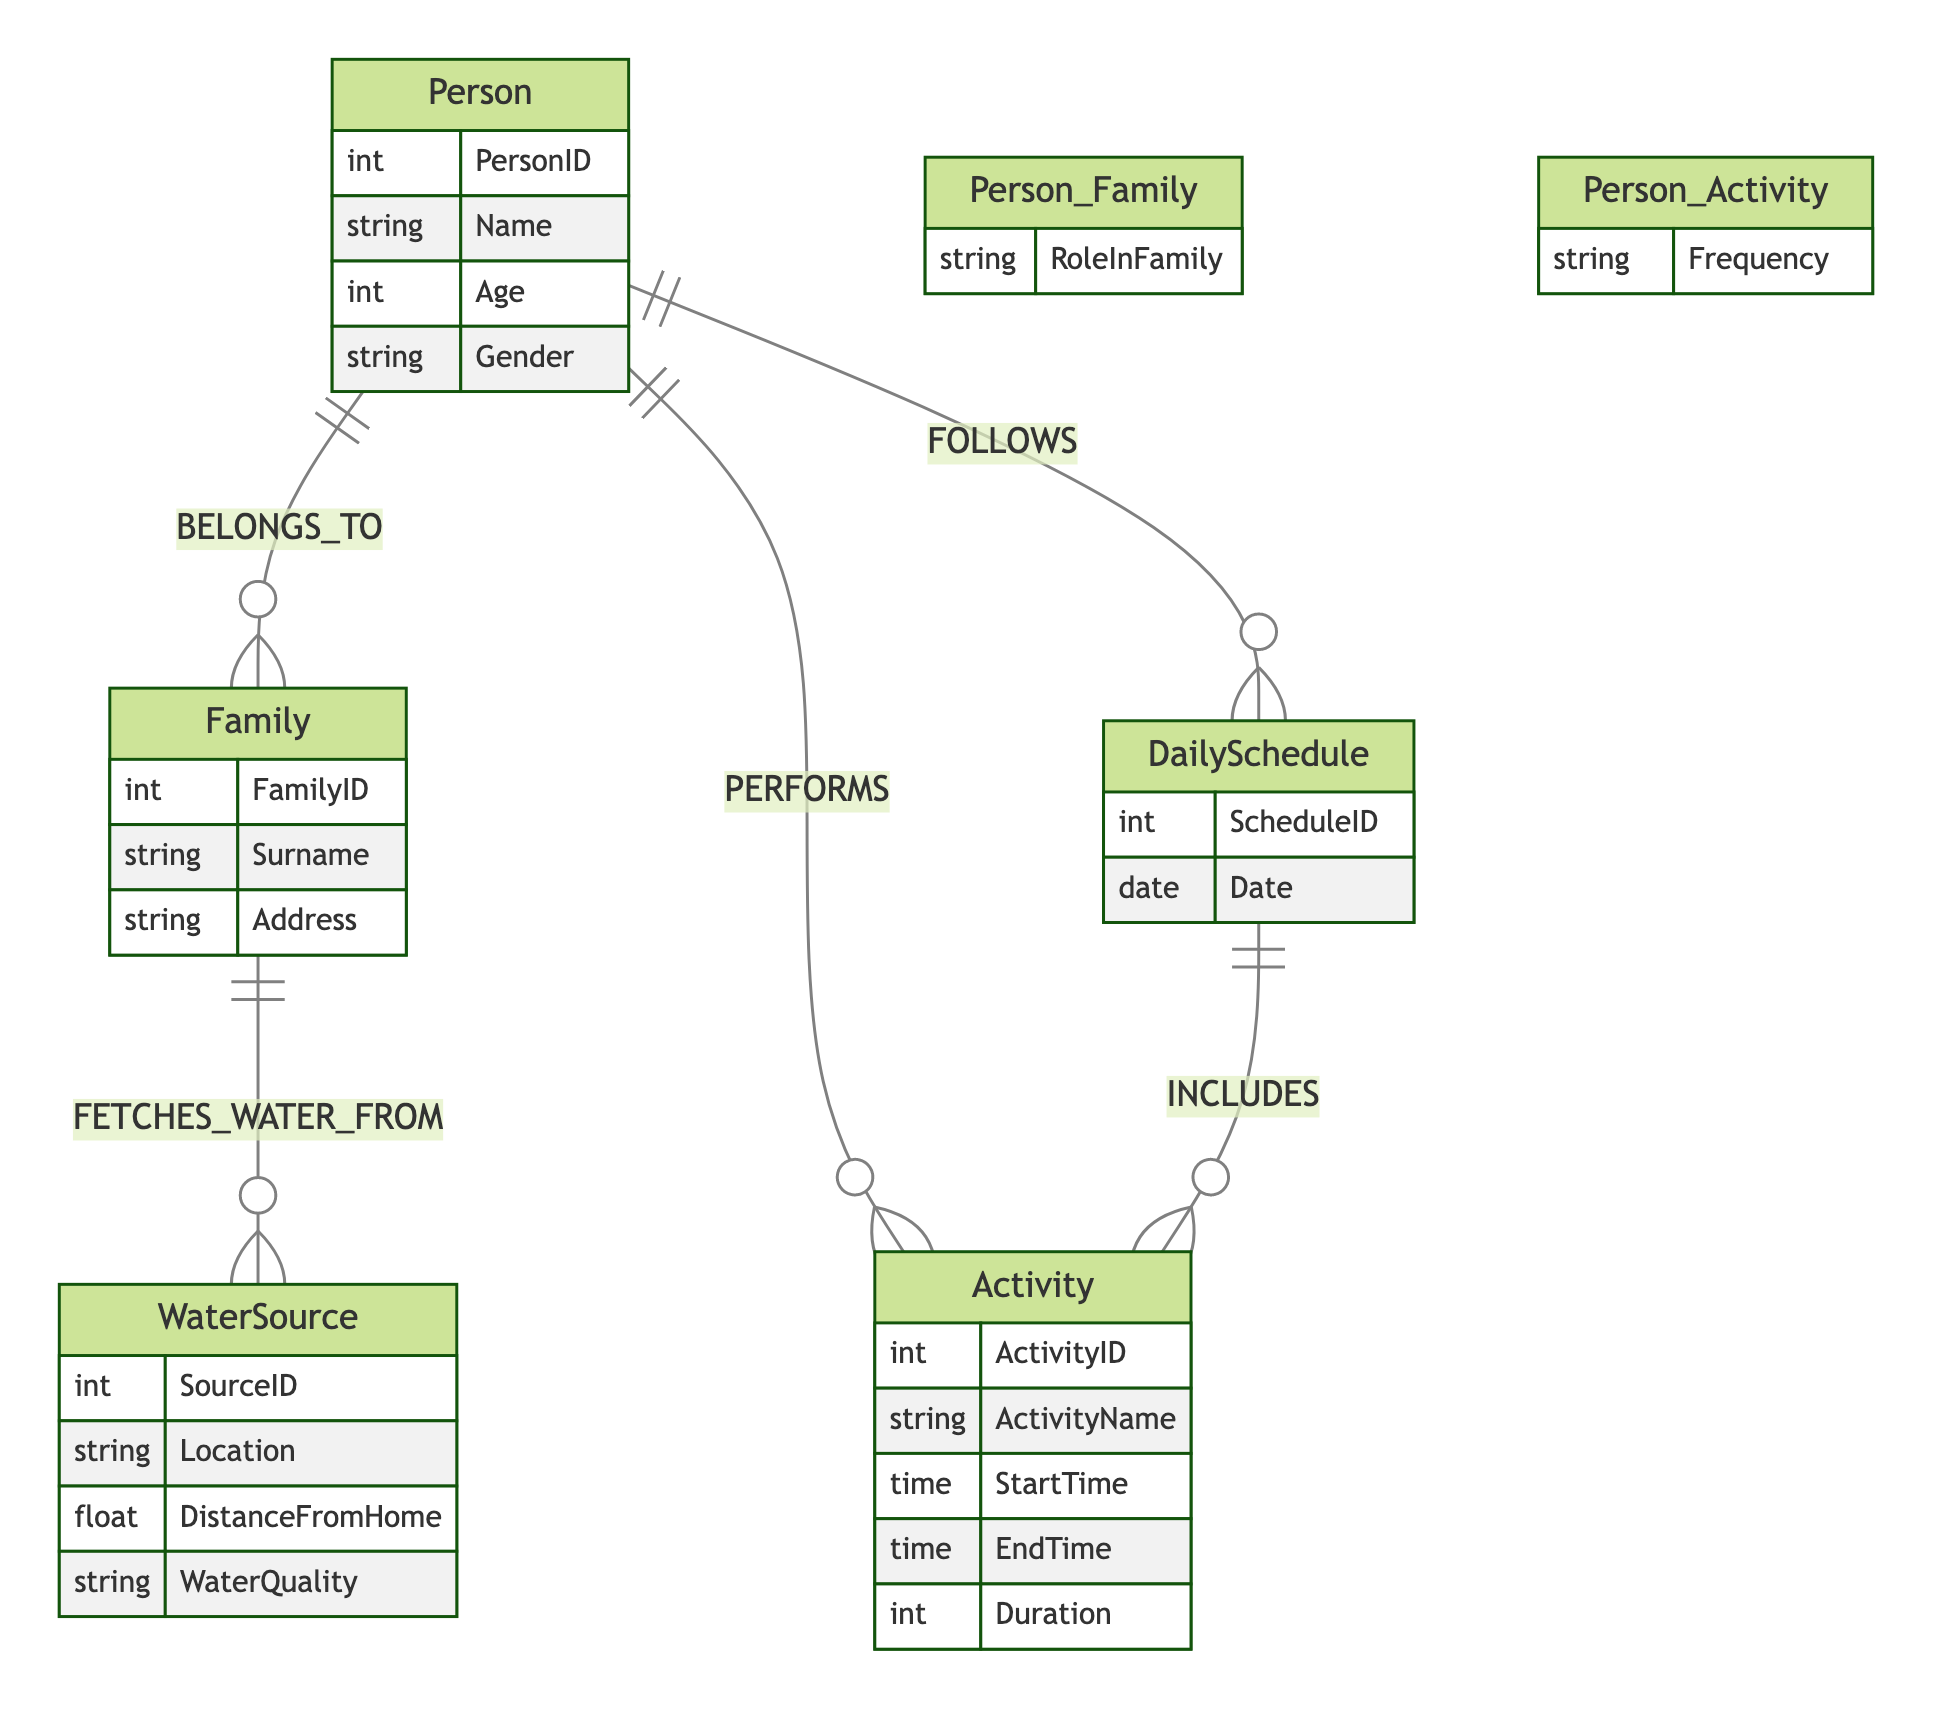What is the relationship between Person and Family? The diagram indicates that the relationship between Person and Family is "BELONGS_TO," which shows that a person is part of a family unit.
Answer: BELONGS_TO How many attributes does the WaterSource entity have? The WaterSource entity contains four attributes: SourceID, Location, DistanceFromHome, and WaterQuality. Therefore, the count of attributes is four.
Answer: four What role can a person have in a family? The diagram specifies the relationship between Person and Family includes an attribute "RoleInFamily," which can represent various roles such as Father, Mother, etc.
Answer: RoleInFamily Which entity does the DailySchedule include? The DailySchedule is related to Activity through the relationship "INCLUDES," indicating that it includes various activities scheduled for a particular day.
Answer: Activity How does a Family relate to WaterSource? The relationship shown between Family and WaterSource is "FETCHES_WATER_FROM," indicating that each family retrieves water from specific water sources.
Answer: FETCHES_WATER_FROM What attributes are in the Activity entity? The Activity entity is defined by five attributes: ActivityID, ActivityName, StartTime, EndTime, and Duration, providing comprehensive details about each activity.
Answer: ActivityID, ActivityName, StartTime, EndTime, Duration Which entity is directly linked to the DailySchedule entity? The diagram clearly indicates that the DailySchedule entity is directly linked to both Activity and Person, through the relationships "INCLUDES" and "FOLLOWS," respectively.
Answer: Activity, Person How many entities are present in the diagram? The diagram consists of five entities: Person, Family, WaterSource, Activity, and DailySchedule, totaling five distinct entities described.
Answer: five What is the frequency attribute related to? The attribute "Frequency" is associated with the relationship between Person and Activity, representing how often a person performs specific activities.
Answer: Activity 